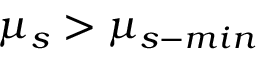<formula> <loc_0><loc_0><loc_500><loc_500>\mu _ { s } > \mu _ { s - \min }</formula> 